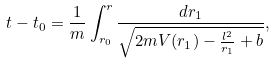Convert formula to latex. <formula><loc_0><loc_0><loc_500><loc_500>t - t _ { 0 } = \frac { 1 } { m } \int _ { r _ { 0 } } ^ { r } \frac { d r _ { 1 } } { \sqrt { 2 m V ( r _ { 1 } ) - \frac { l ^ { 2 } } { r _ { 1 } } + b } } ,</formula> 